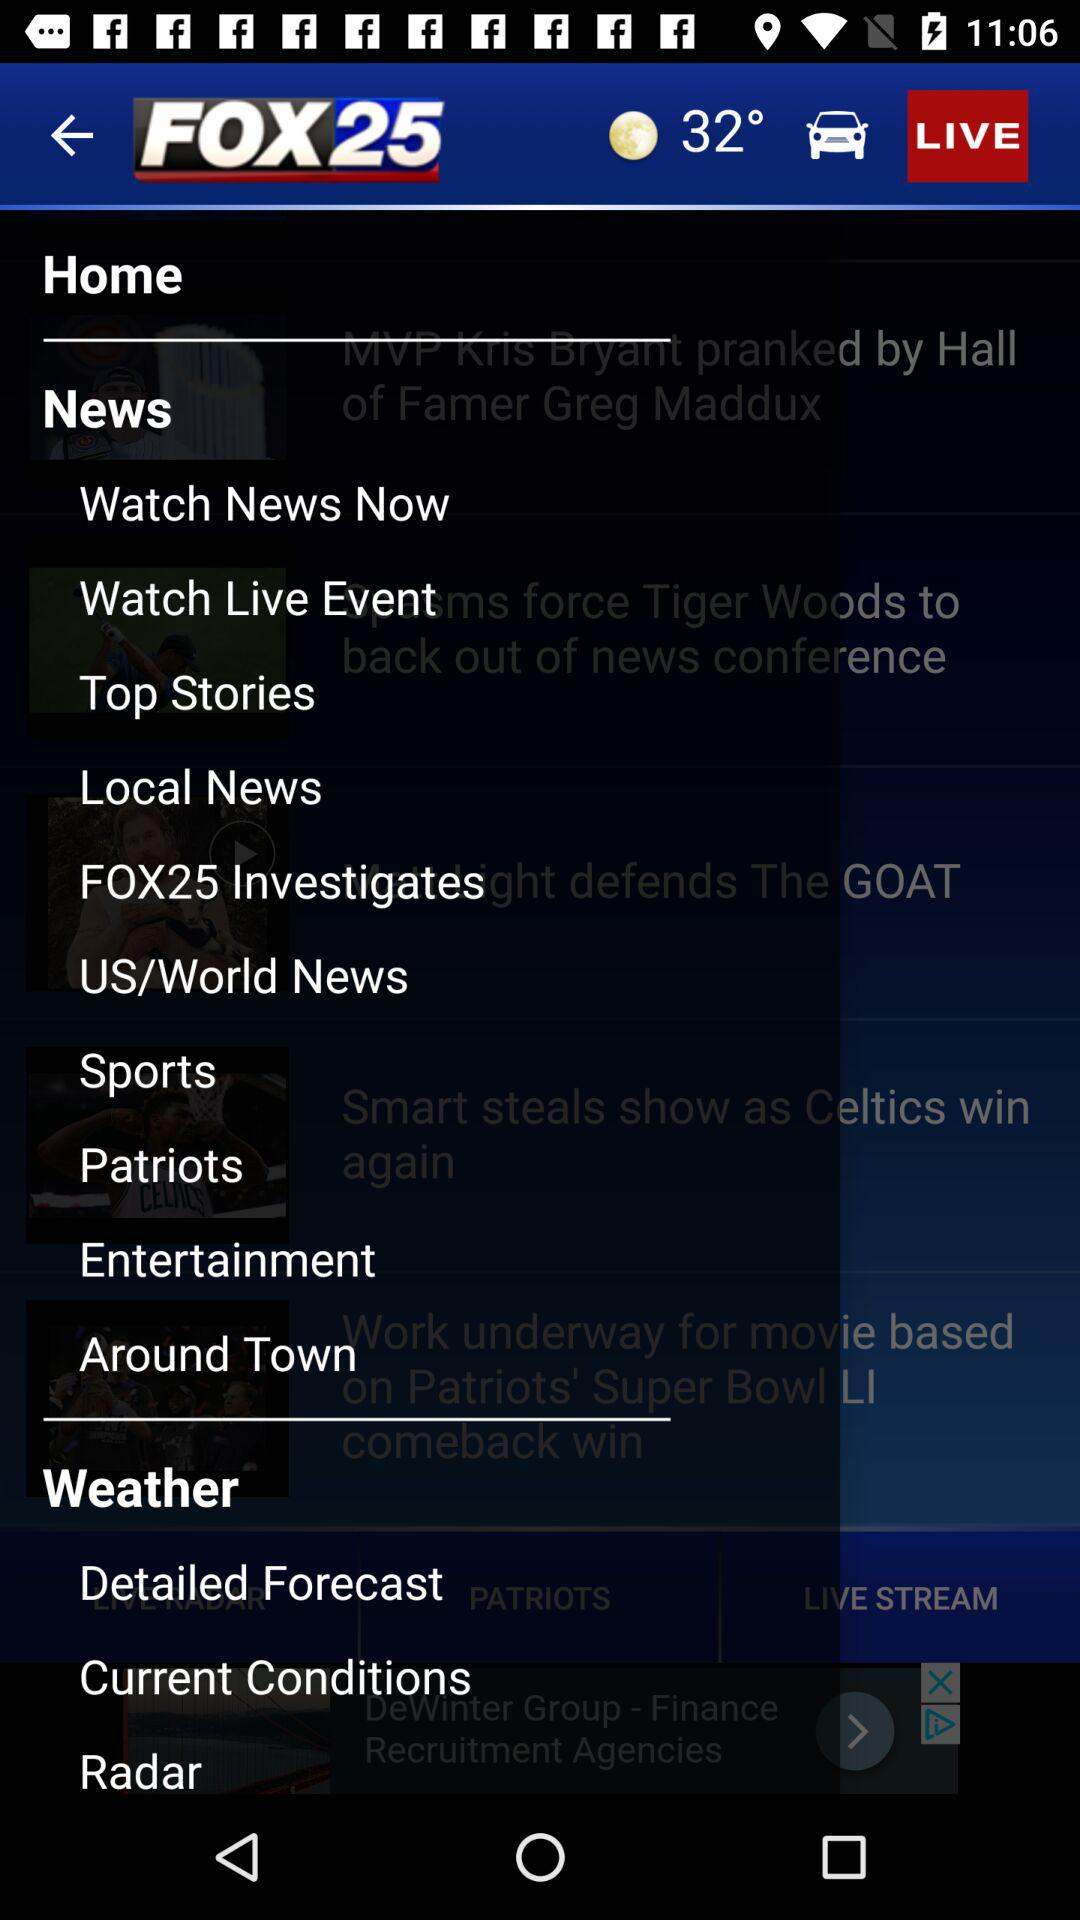What is the name of the application? The name of the application is "FOX25". 